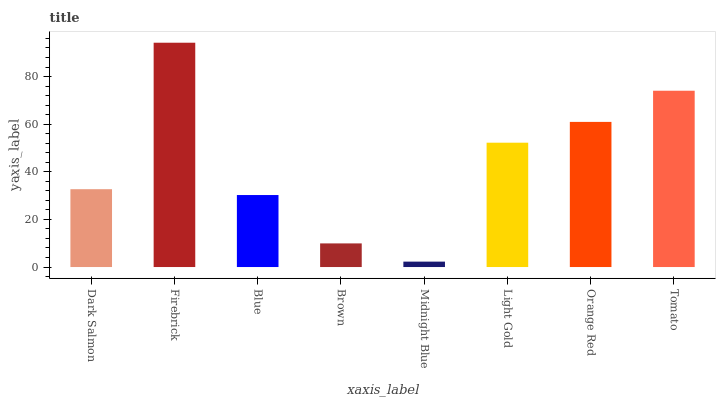Is Midnight Blue the minimum?
Answer yes or no. Yes. Is Firebrick the maximum?
Answer yes or no. Yes. Is Blue the minimum?
Answer yes or no. No. Is Blue the maximum?
Answer yes or no. No. Is Firebrick greater than Blue?
Answer yes or no. Yes. Is Blue less than Firebrick?
Answer yes or no. Yes. Is Blue greater than Firebrick?
Answer yes or no. No. Is Firebrick less than Blue?
Answer yes or no. No. Is Light Gold the high median?
Answer yes or no. Yes. Is Dark Salmon the low median?
Answer yes or no. Yes. Is Midnight Blue the high median?
Answer yes or no. No. Is Firebrick the low median?
Answer yes or no. No. 